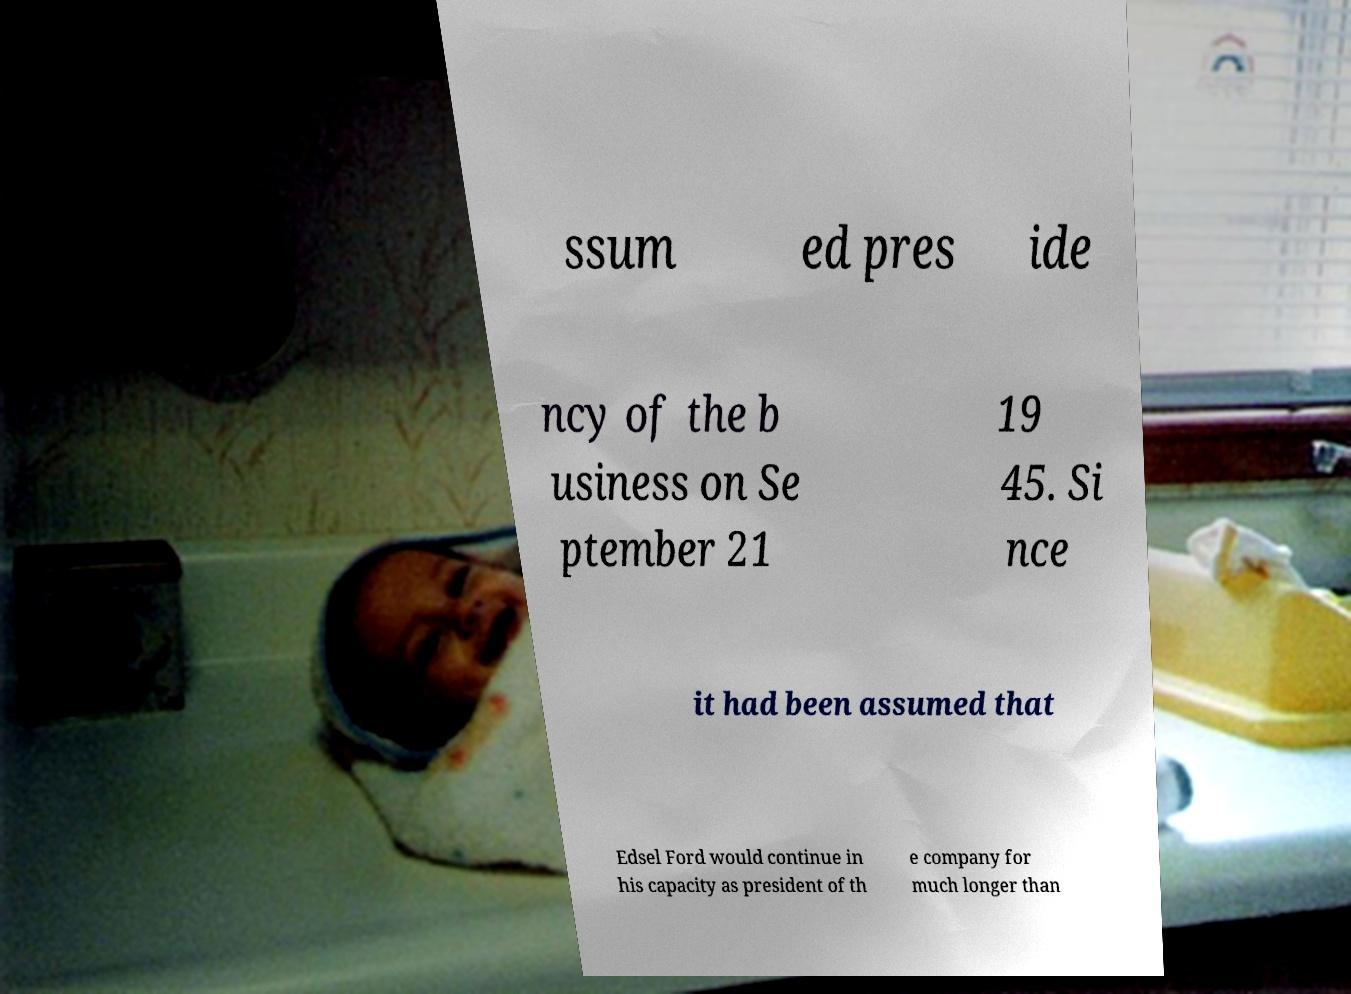Could you assist in decoding the text presented in this image and type it out clearly? ssum ed pres ide ncy of the b usiness on Se ptember 21 19 45. Si nce it had been assumed that Edsel Ford would continue in his capacity as president of th e company for much longer than 